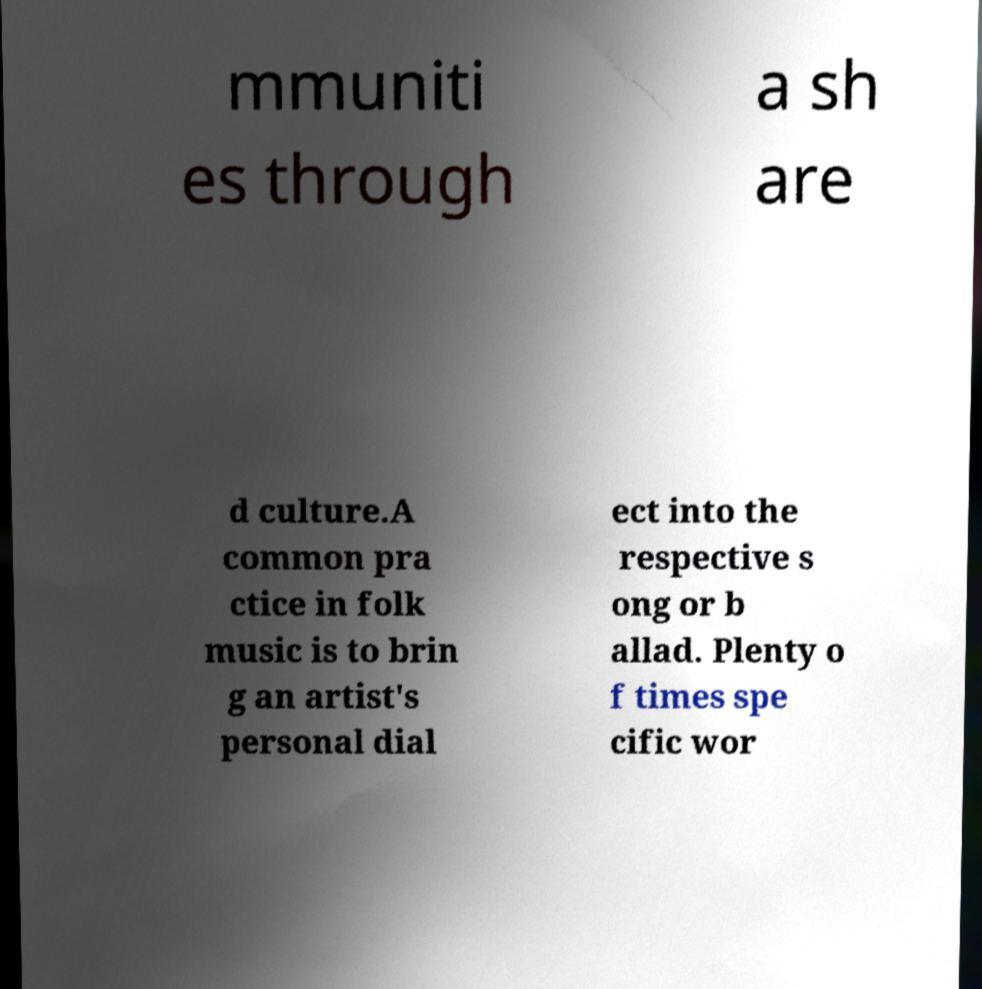Can you read and provide the text displayed in the image?This photo seems to have some interesting text. Can you extract and type it out for me? mmuniti es through a sh are d culture.A common pra ctice in folk music is to brin g an artist's personal dial ect into the respective s ong or b allad. Plenty o f times spe cific wor 